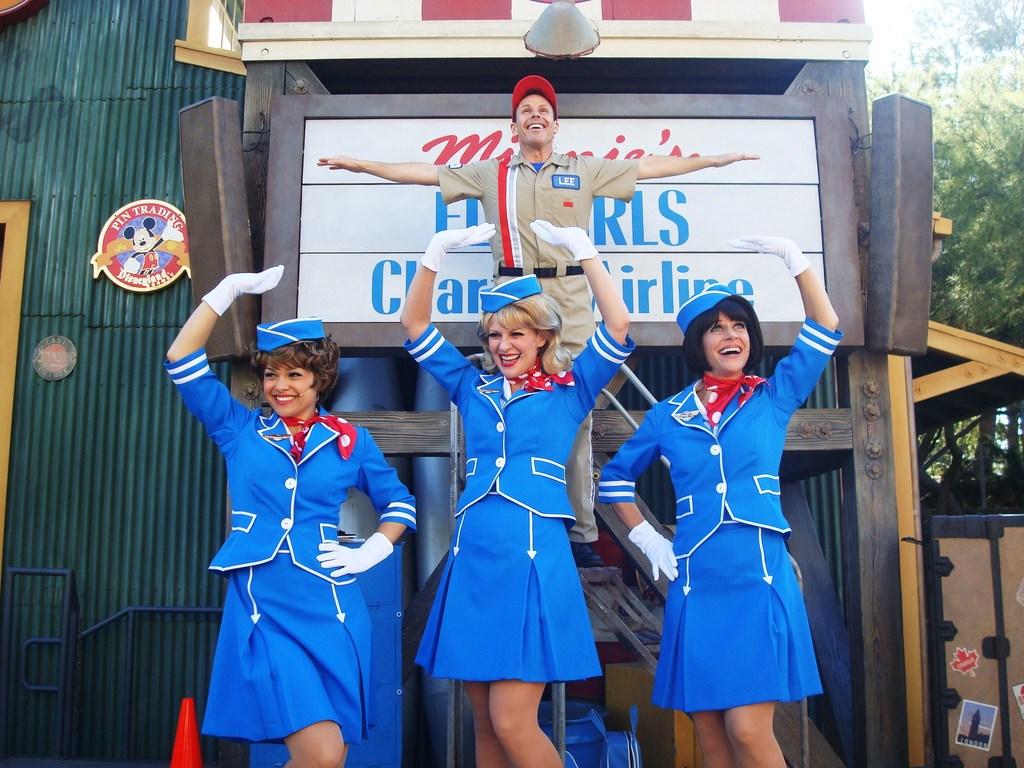What does the sign to the left say they're trading?
Your response must be concise. Pins. 